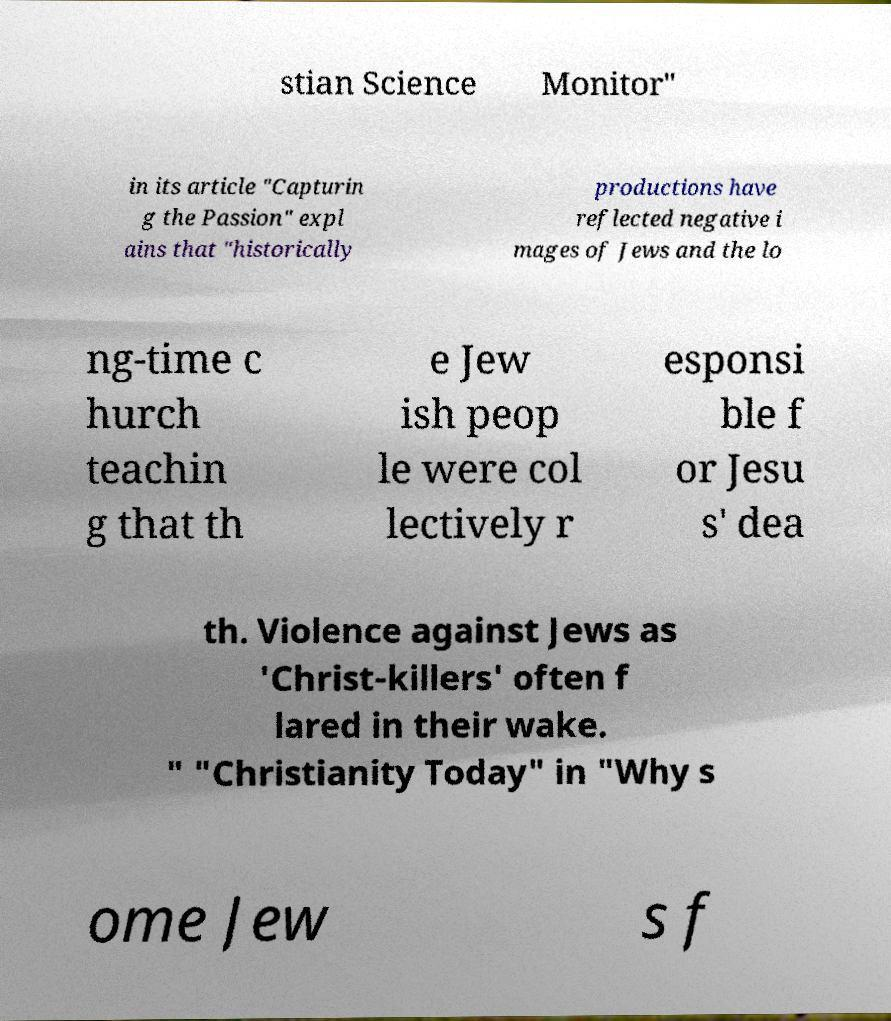Could you extract and type out the text from this image? stian Science Monitor" in its article "Capturin g the Passion" expl ains that "historically productions have reflected negative i mages of Jews and the lo ng-time c hurch teachin g that th e Jew ish peop le were col lectively r esponsi ble f or Jesu s' dea th. Violence against Jews as 'Christ-killers' often f lared in their wake. " "Christianity Today" in "Why s ome Jew s f 